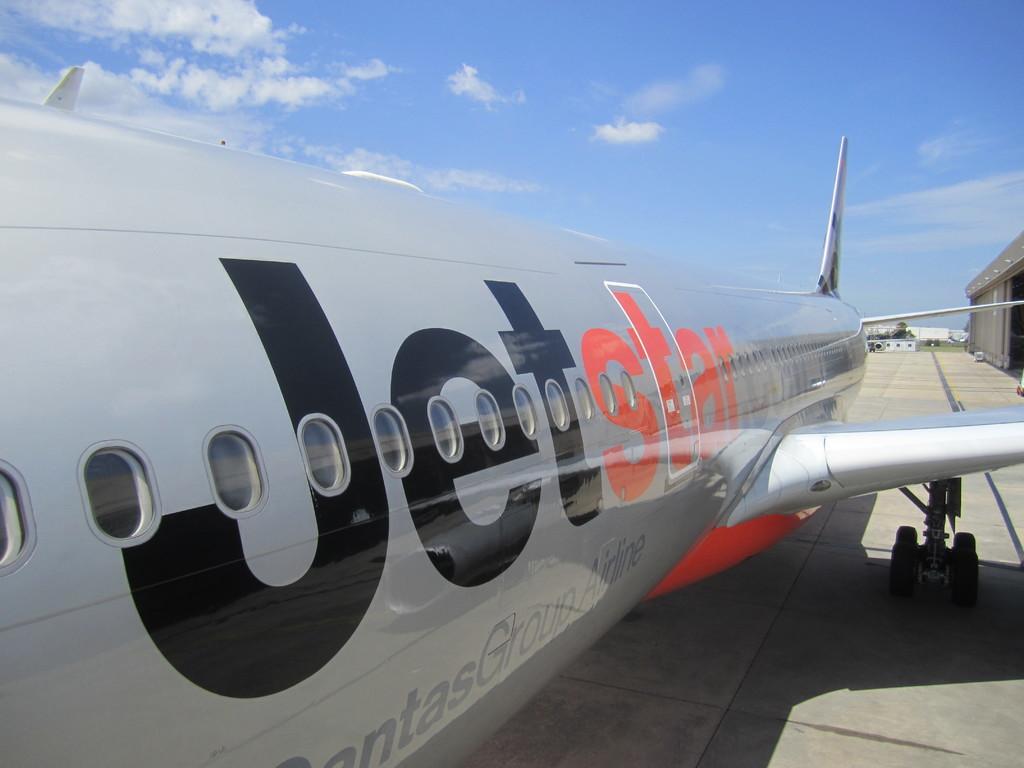What airline is this jet from?
Provide a short and direct response. Jetstar. What colors are the logo?
Offer a terse response. Black and red. 